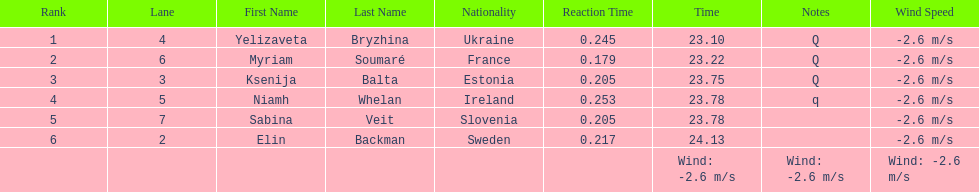Name of athlete who came in first in heat 1 of the women's 200 metres Yelizaveta Bryzhina. 